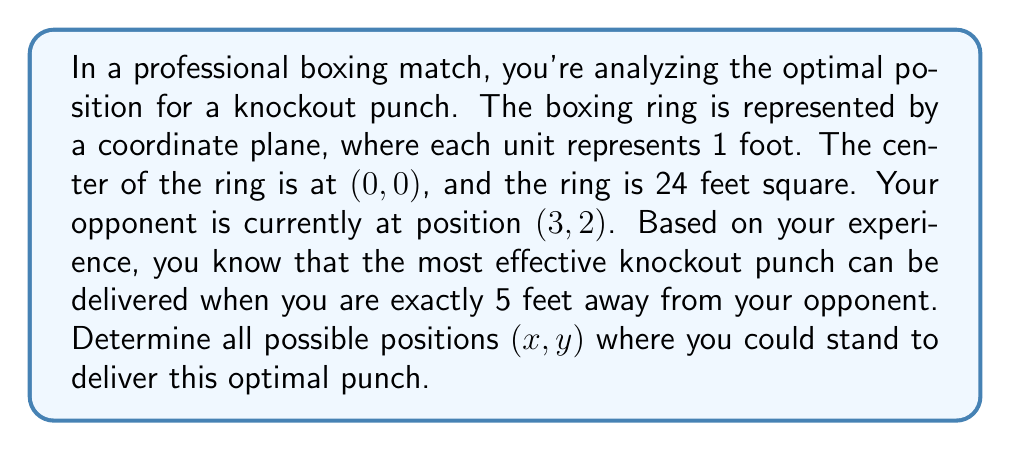Show me your answer to this math problem. To solve this problem, we need to use the distance formula in coordinate geometry. The distance formula between two points (x₁, y₁) and (x₂, y₂) is:

$$d = \sqrt{(x_2 - x_1)^2 + (y_2 - y_1)^2}$$

In this case:
- Your opponent's position is (3, 2), so (x₂, y₂) = (3, 2)
- Your position is (x, y), which we need to find
- The distance between you and your opponent should be 5 feet

Let's plug these into the distance formula:

$$5 = \sqrt{(3 - x)^2 + (2 - y)^2}$$

To solve this, we can square both sides:

$$25 = (3 - x)^2 + (2 - y)^2$$

This is the equation of a circle with center (3, 2) and radius 5. To find all possible positions, we need to solve this equation for x and y:

$$x = 3 \pm \sqrt{25 - (2 - y)^2}$$

or

$$y = 2 \pm \sqrt{25 - (3 - x)^2}$$

These equations represent all points that are 5 feet away from (3, 2). However, we need to consider the constraints of the boxing ring. The ring is 24 feet square, centered at (0, 0), so the valid x and y coordinates must be between -12 and 12.

To visualize this, we can draw the ring and the circle:

[asy]
unitsize(10);
draw((-12,-12)--(12,-12)--(12,12)--(-12,12)--cycle);
draw(circle((3,2),5));
dot((3,2));
label("(3,2)",(3,2),NE);
label("Ring",(0,-13));
label("Optimal punch distance",(8,2));
[/asy]

The intersection of this circle with the square ring represents all possible positions for the optimal punch.
Answer: The optimal positions (x, y) for a knockout punch are all points that satisfy the equation $(3 - x)^2 + (2 - y)^2 = 25$, with $-12 \leq x \leq 12$ and $-12 \leq y \leq 12$. These points form an arc of a circle centered at (3, 2) with radius 5, contained within the 24x24 foot boxing ring. 